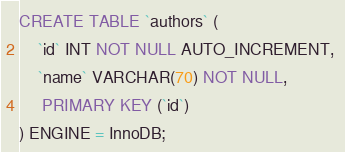<code> <loc_0><loc_0><loc_500><loc_500><_SQL_>CREATE TABLE `authors` ( 
	`id` INT NOT NULL AUTO_INCREMENT, 
	`name` VARCHAR(70) NOT NULL,
	 PRIMARY KEY (`id`)
) ENGINE = InnoDB;</code> 